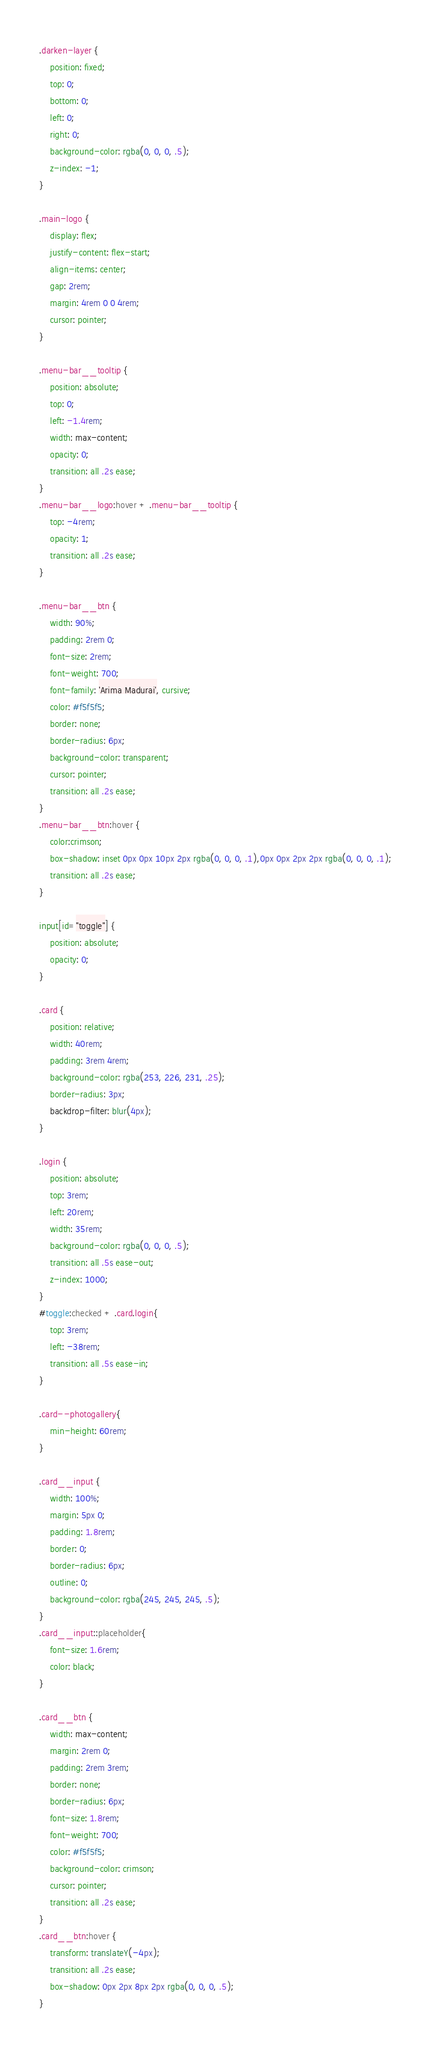<code> <loc_0><loc_0><loc_500><loc_500><_CSS_>.darken-layer {
    position: fixed;
    top: 0;
    bottom: 0;
    left: 0;
    right: 0;
    background-color: rgba(0, 0, 0, .5);
    z-index: -1;
}

.main-logo {
    display: flex;
    justify-content: flex-start;
    align-items: center;
    gap: 2rem;
    margin: 4rem 0 0 4rem;
    cursor: pointer;
}

.menu-bar__tooltip {
    position: absolute;
    top: 0;
    left: -1.4rem;
    width: max-content;
    opacity: 0;
    transition: all .2s ease;
}
.menu-bar__logo:hover + .menu-bar__tooltip {
    top: -4rem;
    opacity: 1;
    transition: all .2s ease;
}

.menu-bar__btn {
    width: 90%;
    padding: 2rem 0;
    font-size: 2rem;
    font-weight: 700;
    font-family: 'Arima Madurai', cursive;
    color: #f5f5f5;
    border: none;
    border-radius: 6px;
    background-color: transparent;
    cursor: pointer;
    transition: all .2s ease;
}
.menu-bar__btn:hover {
    color:crimson;
    box-shadow: inset 0px 0px 10px 2px rgba(0, 0, 0, .1),0px 0px 2px 2px rgba(0, 0, 0, .1);
    transition: all .2s ease;
}

input[id="toggle"] {
    position: absolute;
    opacity: 0;
}

.card {
    position: relative;
    width: 40rem;
    padding: 3rem 4rem;
    background-color: rgba(253, 226, 231, .25);
    border-radius: 3px;
    backdrop-filter: blur(4px);
}

.login {
    position: absolute;
    top: 3rem;
    left: 20rem;
    width: 35rem;
    background-color: rgba(0, 0, 0, .5);
    transition: all .5s ease-out;
    z-index: 1000;
}
#toggle:checked + .card.login{
    top: 3rem;
    left: -38rem;
    transition: all .5s ease-in;
}

.card--photogallery{
    min-height: 60rem;
}

.card__input {
    width: 100%;
    margin: 5px 0;
    padding: 1.8rem;
    border: 0;
    border-radius: 6px;
    outline: 0;
    background-color: rgba(245, 245, 245, .5);
}
.card__input::placeholder{
    font-size: 1.6rem;
    color: black;
}

.card__btn {
    width: max-content;
    margin: 2rem 0;
    padding: 2rem 3rem;
    border: none;
    border-radius: 6px;
    font-size: 1.8rem;
    font-weight: 700;
    color: #f5f5f5;
    background-color: crimson;
    cursor: pointer;
    transition: all .2s ease;
}
.card__btn:hover {
    transform: translateY(-4px);
    transition: all .2s ease;
    box-shadow: 0px 2px 8px 2px rgba(0, 0, 0, .5);
}</code> 